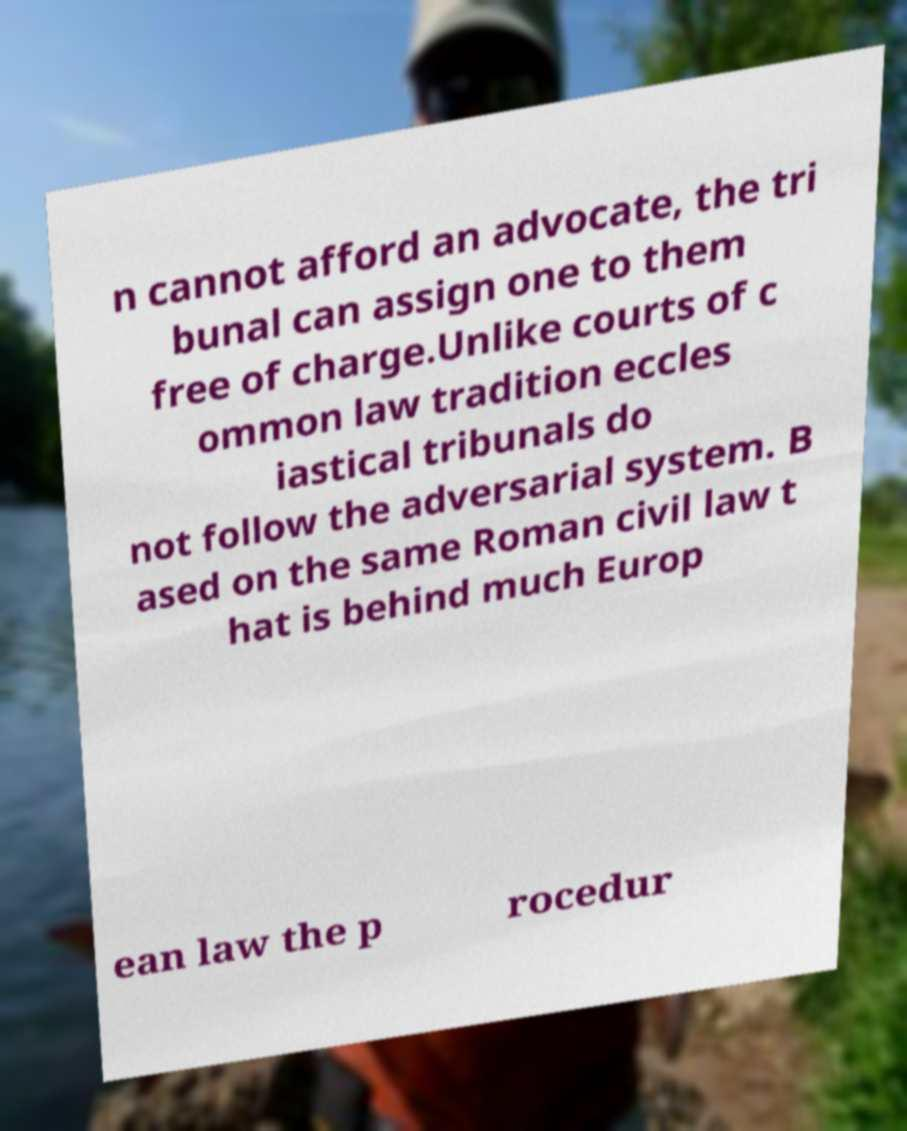Please read and relay the text visible in this image. What does it say? n cannot afford an advocate, the tri bunal can assign one to them free of charge.Unlike courts of c ommon law tradition eccles iastical tribunals do not follow the adversarial system. B ased on the same Roman civil law t hat is behind much Europ ean law the p rocedur 